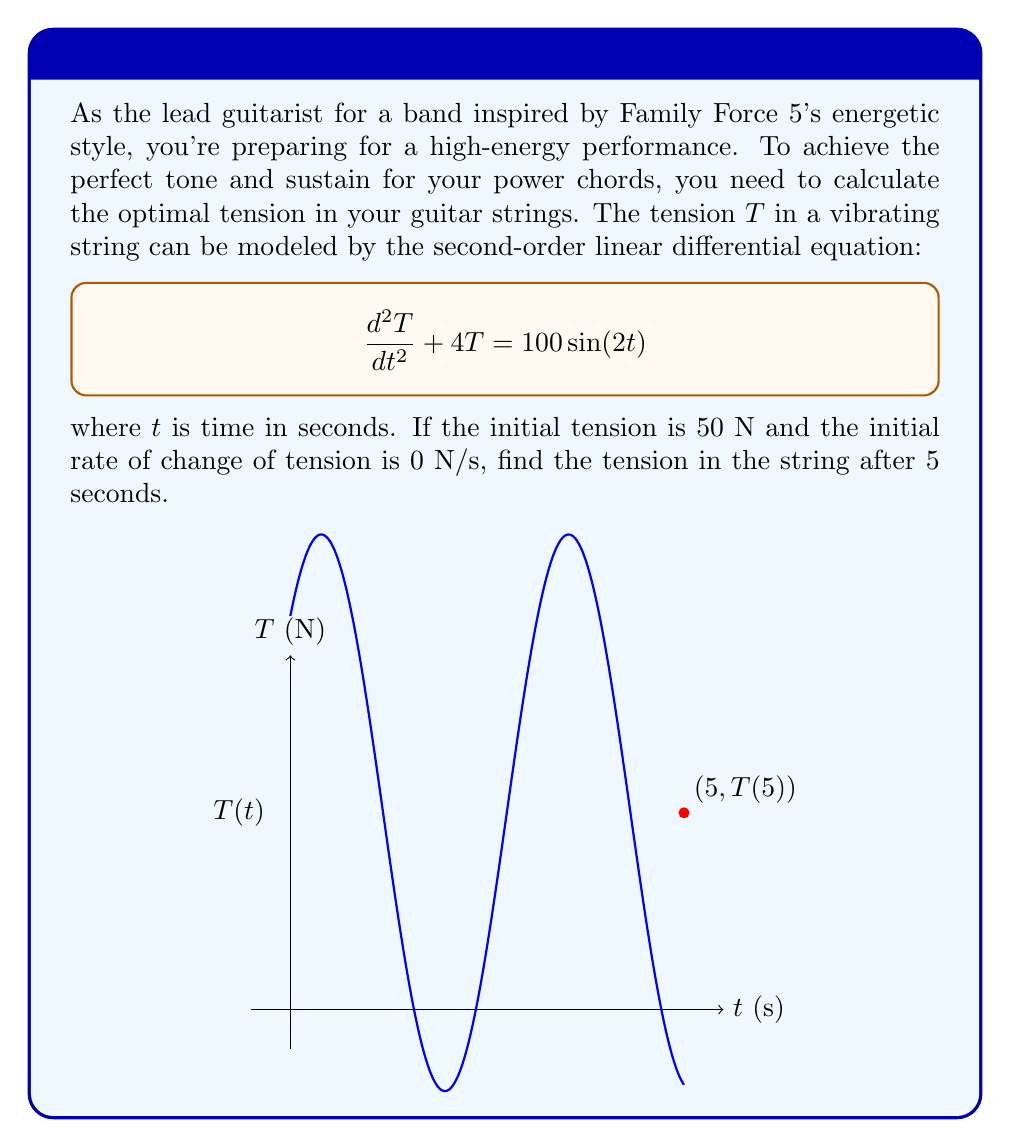Can you answer this question? Let's solve this step-by-step:

1) The general solution for this equation is of the form:
   $$T(t) = A\cos(2t) + B\sin(2t) + 25$$

2) We need to find $A$ and $B$ using the initial conditions:
   $T(0) = 50$ and $T'(0) = 0$

3) From $T(0) = 50$:
   $$50 = A\cos(0) + B\sin(0) + 25$$
   $$50 = A + 25$$
   $$A = 25$$

4) From $T'(t) = -2A\sin(2t) + 2B\cos(2t)$, we get:
   $T'(0) = 0 = -2A\sin(0) + 2B\cos(0) = 2B$
   $$B = 0$$

5) Therefore, the particular solution is:
   $$T(t) = 25\cos(2t) + 25$$

6) To find $T(5)$, we substitute $t=5$:
   $$T(5) = 25\cos(10) + 25$$

7) Using a calculator or knowing that $\cos(10) \approx -0.8390715290764524$:
   $$T(5) \approx 25(-0.8390715290764524) + 25 \approx 4.0232118730588695$$
Answer: $T(5) \approx 4.02$ N 